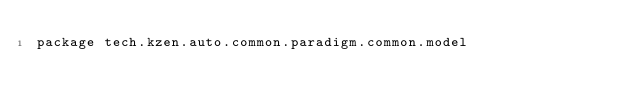<code> <loc_0><loc_0><loc_500><loc_500><_Kotlin_>package tech.kzen.auto.common.paradigm.common.model
</code> 